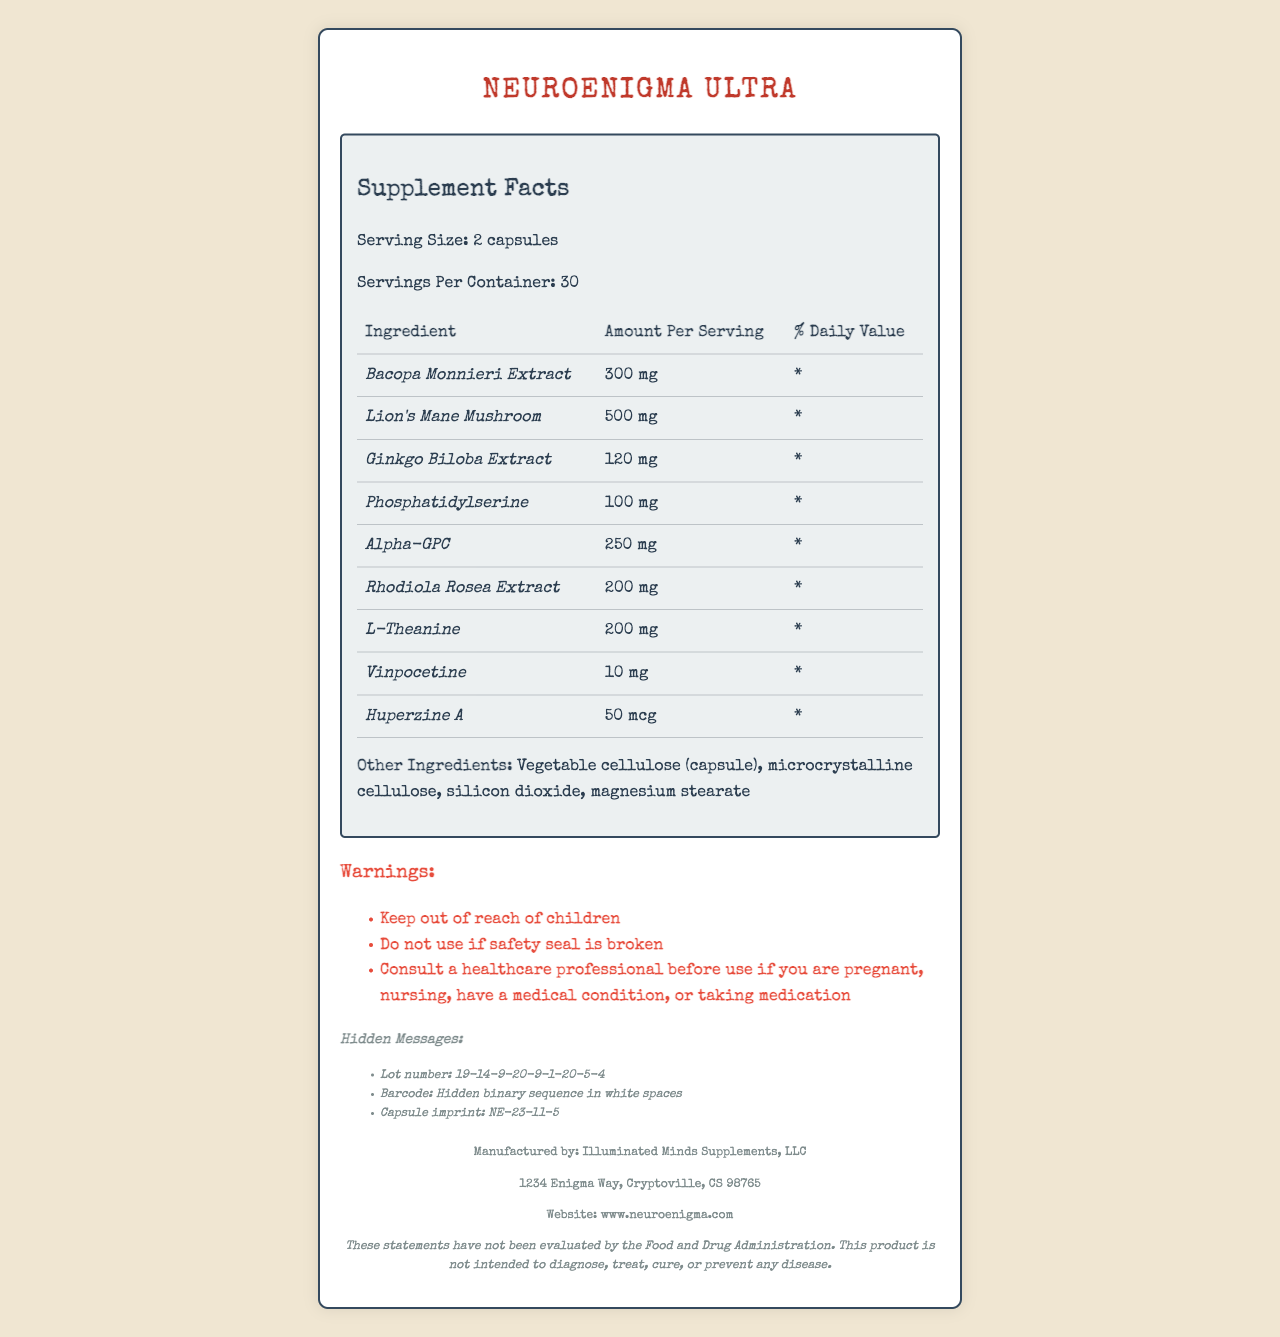what is the serving size? The document explicitly states the serving size as "2 capsules."
Answer: 2 capsules how many servings are in one container? The document indicates that there are 30 servings per container.
Answer: 30 which ingredient has the highest amount per serving? The Lion's Mane Mushroom has the highest amount at 500 mg per serving.
Answer: Lion's Mane Mushroom what is the daily value for Bacopa Monnieri Extract? The daily value for Bacopa Monnieri Extract is marked as "*" in the document.
Answer: * what are the other ingredients listed? The document lists the other ingredients under the section "Other Ingredients."
Answer: Vegetable cellulose (capsule), microcrystalline cellulose, silicon dioxide, magnesium stearate what are the warnings associated with this product? The document provides three warnings under the "Warnings" section.
Answer: Keep out of reach of children; Do not use if safety seal is broken; Consult a healthcare professional before use if you are pregnant, nursing, have a medical condition, or taking medication where can I find hidden messages in this product? The document indicates the locations of hidden messages as the lot number, barcode, and capsule imprint.
Answer: Lot number, Barcode, Capsule imprint who manufactures NeuroEnigma Ultra? The manufacturer is listed at the bottom of the document as Illuminated Minds Supplements, LLC.
Answer: Illuminated Minds Supplements, LLC what is the main address of the manufacturer? The address is provided in the footer of the document.
Answer: 1234 Enigma Way, Cryptoville, CS 98765 what is the percentage of daily value for any of the ingredients? All ingredients listed have a daily value marked as "*".
Answer: * how much Vinpocetine is in a serving? The amount of Vinpocetine per serving is listed as 10 mg in the document.
Answer: 10 mg which ingredient has the smallest amount per serving? Huperzine A has the smallest amount at 50 mcg per serving.
Answer: Huperzine A does the product have a disclaimer regarding FDA evaluation? The disclaimer regarding FDA evaluation is located at the bottom of the document.
Answer: Yes what is the cryptic message in the lot number? The cryptic message in the lot number is "19-14-9-20-9-1-20-5-4" as indicated in the cryptic messages section.
Answer: 19-14-9-20-9-1-20-5-4 which ingredient is NOT listed in the NeuroEnigma Ultra? A. Bacopa Monnieri Extract B. Ashwagandha C. L-Theanine D. Ginkgo Biloba Extract Ashwagandha is not listed in the ingredients of NeuroEnigma Ultra.
Answer: B which of the following is a warning for the product? A. Not suitable for children B. Store in a cool, dry place C. Do not use if safety seal is broken D. Avoid exposure to sunlight "Do not use if safety seal is broken" is specifically mentioned as a warning in the document.
Answer: C is there a hidden binary sequence mentioned in the document? The document mentions a hidden binary sequence in the white spaces of the barcode.
Answer: Yes summarize the document. The document serves to provide comprehensive information about the NeuroEnigma Ultra supplement, including its components, usage instructions, potential precautions, and some hidden, cryptic messages for enthusiasts.
Answer: The document is a Supplement Facts label for NeuroEnigma Ultra, a brain-enhancing product. It includes detailed information about serving size, servings per container, ingredients with amounts, other ingredients, warnings, and cryptic messages hidden in various locations. The product is manufactured by Illuminated Minds Supplements, LLC, with an address provided. Additionally, there is an FDA disclaimer indicating that the statements have not been evaluated by the Food and Drug Administration. how does the manufacturer recommend you consult for use if you have a medical condition or are taking medication? The document advises consulting a healthcare professional if you have a medical condition or are taking medication.
Answer: Consult a healthcare professional what is the specific code on the capsule imprint? The capsule imprint cryptic message is "NE-23-11-5" as listed in the cryptic messages section.
Answer: NE-23-11-5 how does the barcode contain a hidden message? The barcode is mentioned to contain a hidden binary sequence in its white spaces.
Answer: Hidden binary sequence in white spaces what is the expiration date for this product? The document does not provide information about the expiration date.
Answer: Cannot be determined 